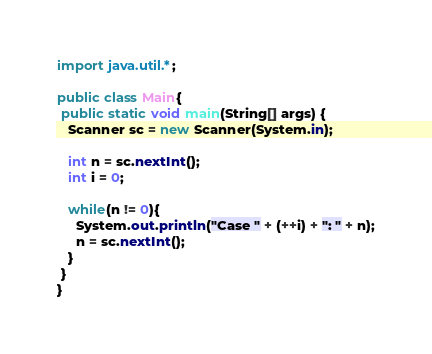Convert code to text. <code><loc_0><loc_0><loc_500><loc_500><_Java_>import java.util.*;

public class Main{
 public static void main(String[] args) {
   Scanner sc = new Scanner(System.in);
   
   int n = sc.nextInt();
   int i = 0;
   
   while(n != 0){
     System.out.println("Case " + (++i) + ": " + n);
     n = sc.nextInt();
   }
 }
}</code> 